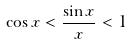<formula> <loc_0><loc_0><loc_500><loc_500>\cos x < \frac { \sin x } { x } < 1</formula> 